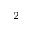Convert formula to latex. <formula><loc_0><loc_0><loc_500><loc_500>^ { 2 }</formula> 